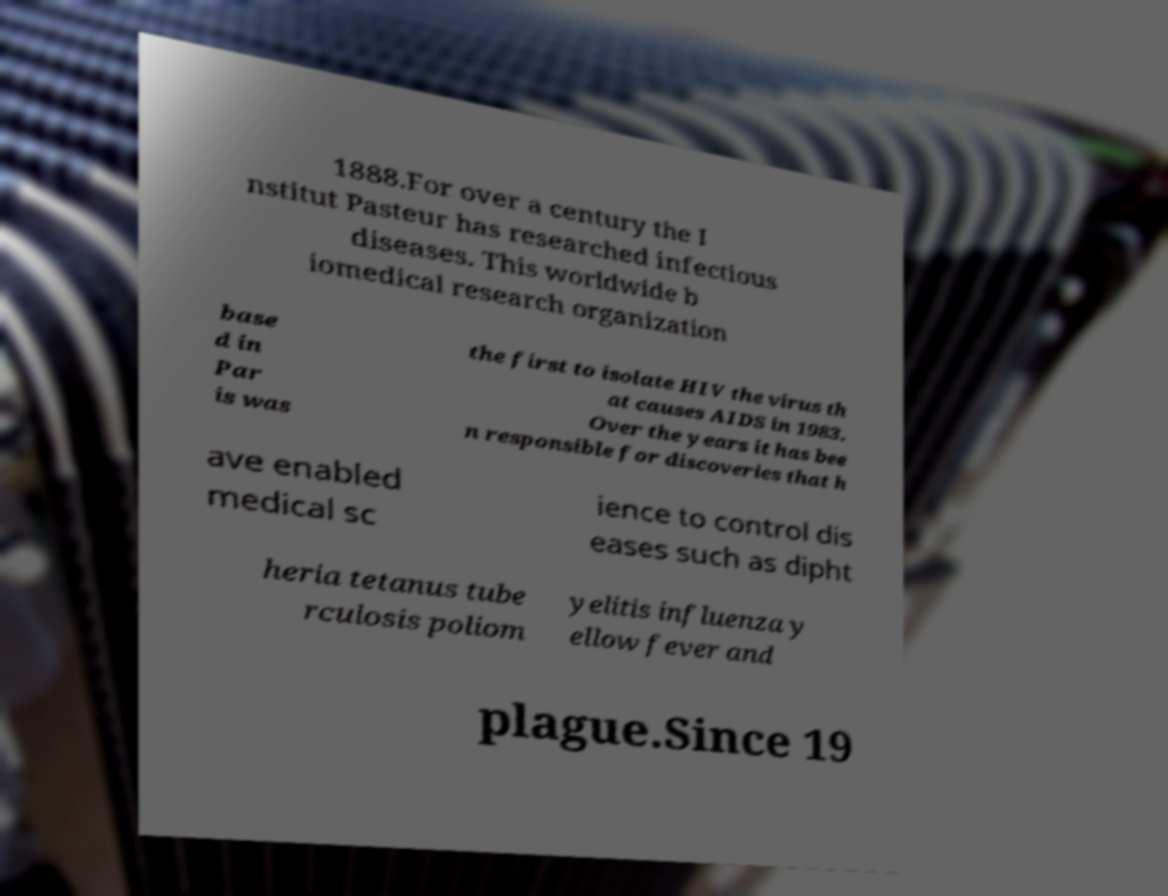Please identify and transcribe the text found in this image. 1888.For over a century the I nstitut Pasteur has researched infectious diseases. This worldwide b iomedical research organization base d in Par is was the first to isolate HIV the virus th at causes AIDS in 1983. Over the years it has bee n responsible for discoveries that h ave enabled medical sc ience to control dis eases such as dipht heria tetanus tube rculosis poliom yelitis influenza y ellow fever and plague.Since 19 